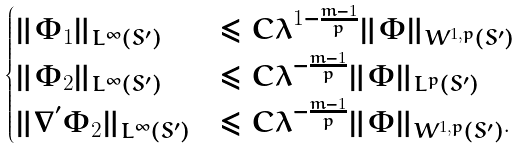<formula> <loc_0><loc_0><loc_500><loc_500>\begin{cases} \| \Phi _ { 1 } \| _ { L ^ { \infty } ( S ^ { \prime } ) } & \leq C \lambda ^ { 1 - \frac { m - 1 } { p } } \| \Phi \| _ { W ^ { 1 , p } ( S ^ { \prime } ) } \\ \| \Phi _ { 2 } \| _ { L ^ { \infty } ( S ^ { \prime } ) } & \leq C \lambda ^ { - \frac { m - 1 } { p } } \| \Phi \| _ { L ^ { p } ( S ^ { \prime } ) } \\ \| \nabla ^ { ^ { \prime } } \Phi _ { 2 } \| _ { L ^ { \infty } ( S ^ { \prime } ) } & \leq C \lambda ^ { - \frac { m - 1 } { p } } \| \Phi \| _ { W ^ { 1 , p } ( S ^ { \prime } ) } . \end{cases}</formula> 